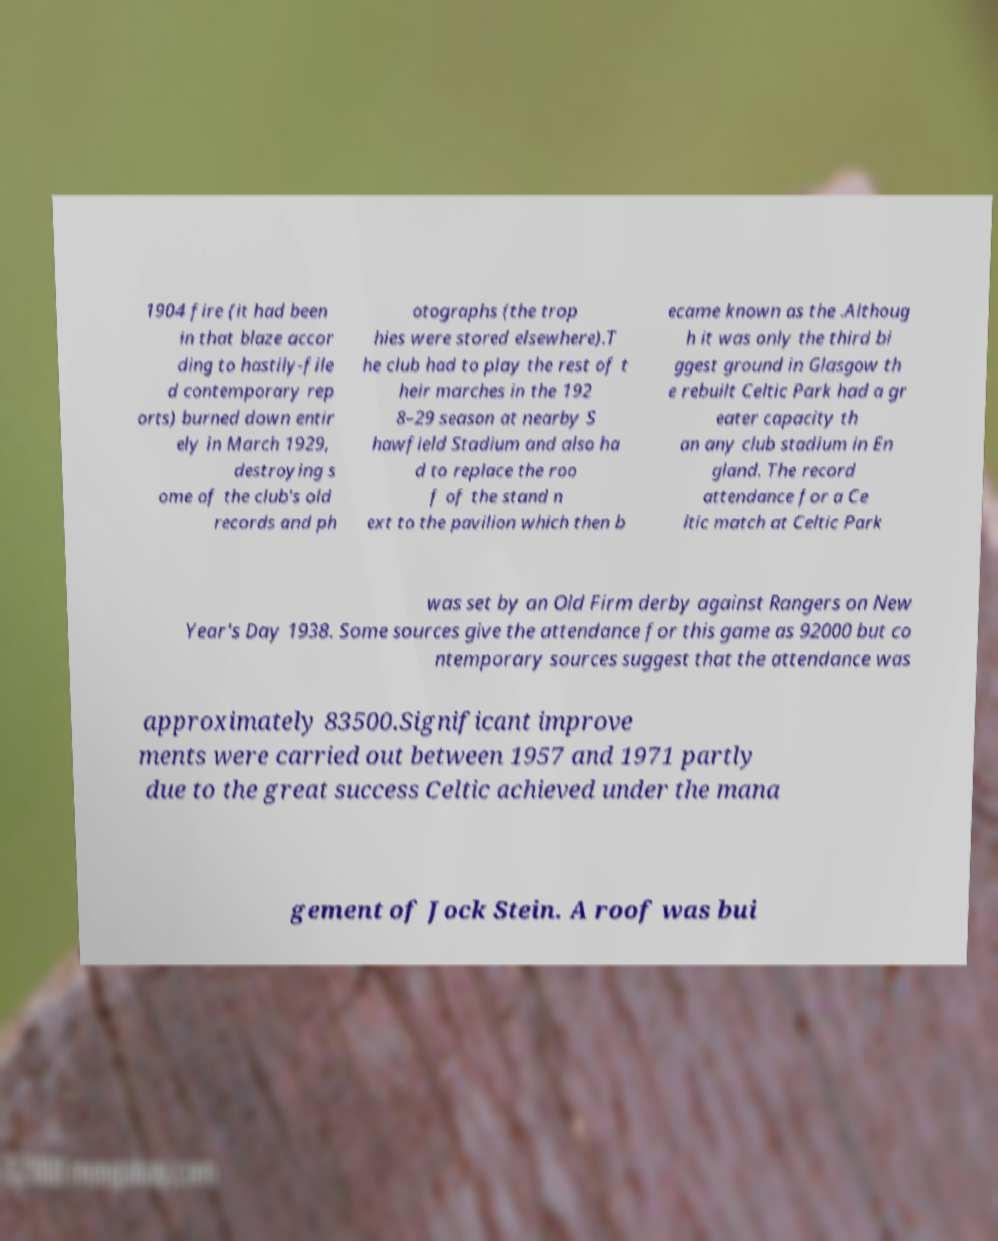Can you read and provide the text displayed in the image?This photo seems to have some interesting text. Can you extract and type it out for me? 1904 fire (it had been in that blaze accor ding to hastily-file d contemporary rep orts) burned down entir ely in March 1929, destroying s ome of the club's old records and ph otographs (the trop hies were stored elsewhere).T he club had to play the rest of t heir marches in the 192 8–29 season at nearby S hawfield Stadium and also ha d to replace the roo f of the stand n ext to the pavilion which then b ecame known as the .Althoug h it was only the third bi ggest ground in Glasgow th e rebuilt Celtic Park had a gr eater capacity th an any club stadium in En gland. The record attendance for a Ce ltic match at Celtic Park was set by an Old Firm derby against Rangers on New Year's Day 1938. Some sources give the attendance for this game as 92000 but co ntemporary sources suggest that the attendance was approximately 83500.Significant improve ments were carried out between 1957 and 1971 partly due to the great success Celtic achieved under the mana gement of Jock Stein. A roof was bui 